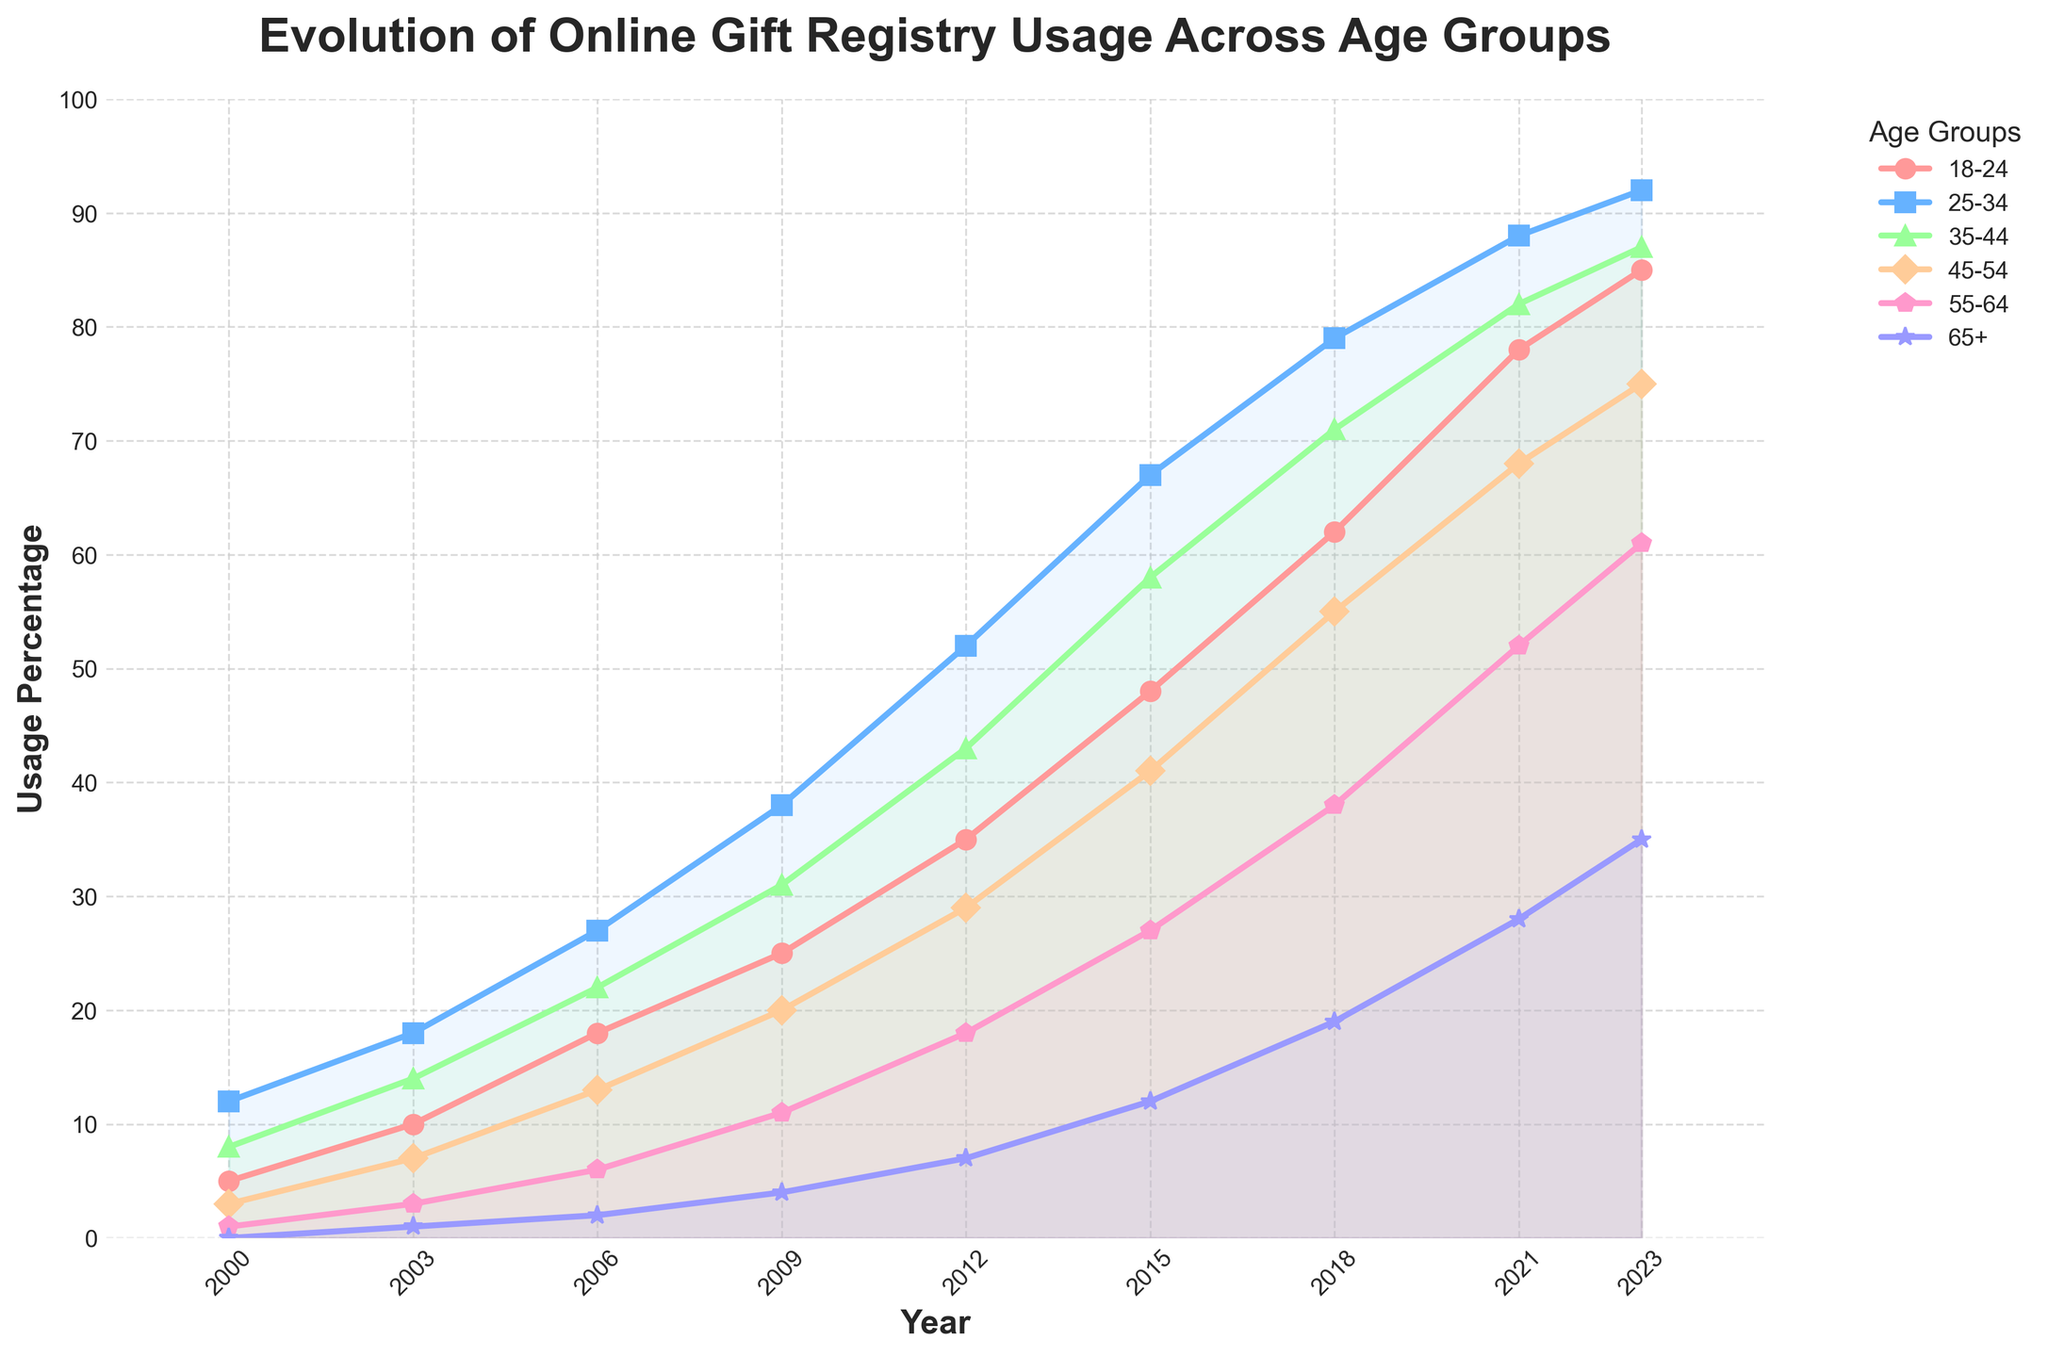What are the trends over time for the 18-24 age group? The line chart indicates a steady increase in online gift registry usage for the 18-24 age group from 5% in 2000 to 85% in 2023. This shows a significant and continuous rise in this age group's usage over the years.
Answer: Steady increase Which age group has the highest usage percentage in 2023? To find the highest usage percentage in 2023, we look at the values at the end of each line. The 25-34 age group shows the highest usage percentage in 2023 with 92%.
Answer: 25-34 Which two age groups had the sharpest increase in usage between 2006 and 2009? By examining the slopes of the lines between 2006 and 2009, the sharpest increases can be seen in the 18-24 age group (from 18% to 25%) and the 25-34 age group (from 27% to 38%).
Answer: 18-24 and 25-34 What is the overall average usage percentage for the 55-64 age group from 2000 to 2023? Calculating the average involves summing up all the usage percentages from 2000 to 2023 for the 55-64 age group: (1 + 3 + 6 + 11 + 18 + 27 + 38 + 52 + 61)/9 = 24.33%.
Answer: 24.33% Is there any age group whose usage percentage has remained below 50% throughout the years? Checking all age groups from 2000 to 2023, the 65+ age group has always remained below 50%, with the highest being 35% in 2023.
Answer: 65+ How does the growth rate of online gift registry usage compare between the 35-44 and 45-54 age groups from 2000 to 2018? To determine the growth rate, subtract the initial value from the final value for each group and divide by the number of years (2018-2000=18 years). For the 35-44 age group: (71-8)/18 = 3.50% per year. For the 45-54 age group: (55-3)/18 ≈ 2.89% per year. The 35-44 age group has a higher growth rate.
Answer: 35-44 age group Between which consecutive years did the 25-34 age group see the largest increase in usage percentage? Examining the year-over-year differences for the 25-34 age group, the largest increase occurs between 2009 and 2012 (52% - 38% = 14%).
Answer: 2009 and 2012 What is the difference in usage percentage between the 18-24 and 65+ age groups in 2023? The values for 2023 for 18-24 is 85% and for 65+ is 35%. The difference is 85% - 35% = 50%.
Answer: 50% Which age group experienced the most consistent growth in online gift registry usage over the period? By looking at the smoothness and steepness of the lines, the 18-24 age group shows the most consistent and steady growth without major fluctuations, rising steadily from 5% in 2000 to 85% in 2023.
Answer: 18-24 